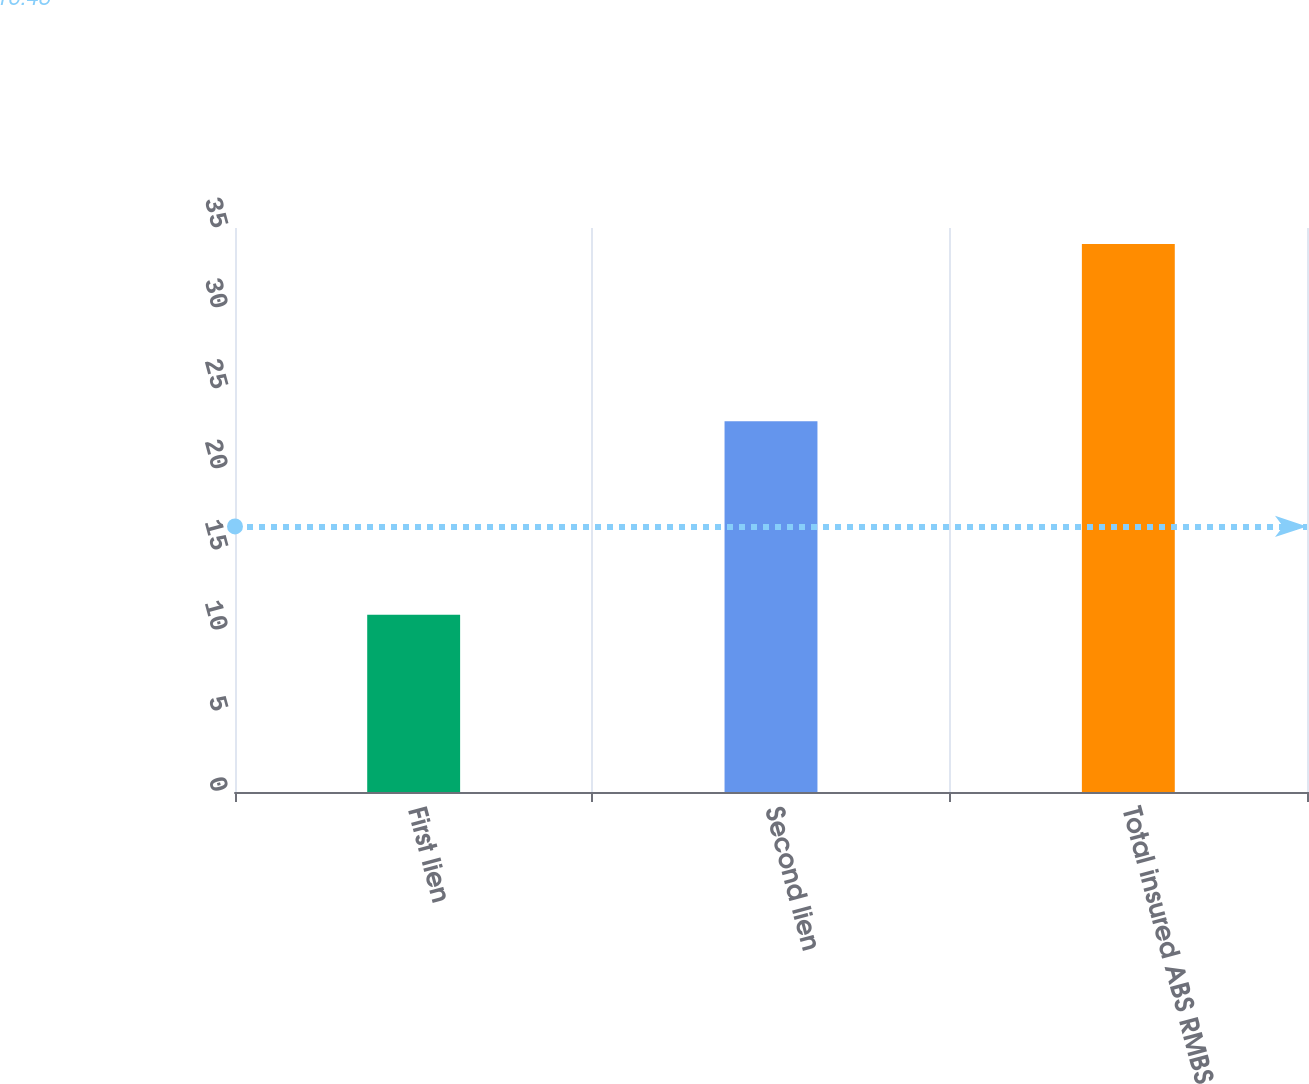Convert chart to OTSL. <chart><loc_0><loc_0><loc_500><loc_500><bar_chart><fcel>First lien<fcel>Second lien<fcel>Total insured ABS RMBS<nl><fcel>11<fcel>23<fcel>34<nl></chart> 